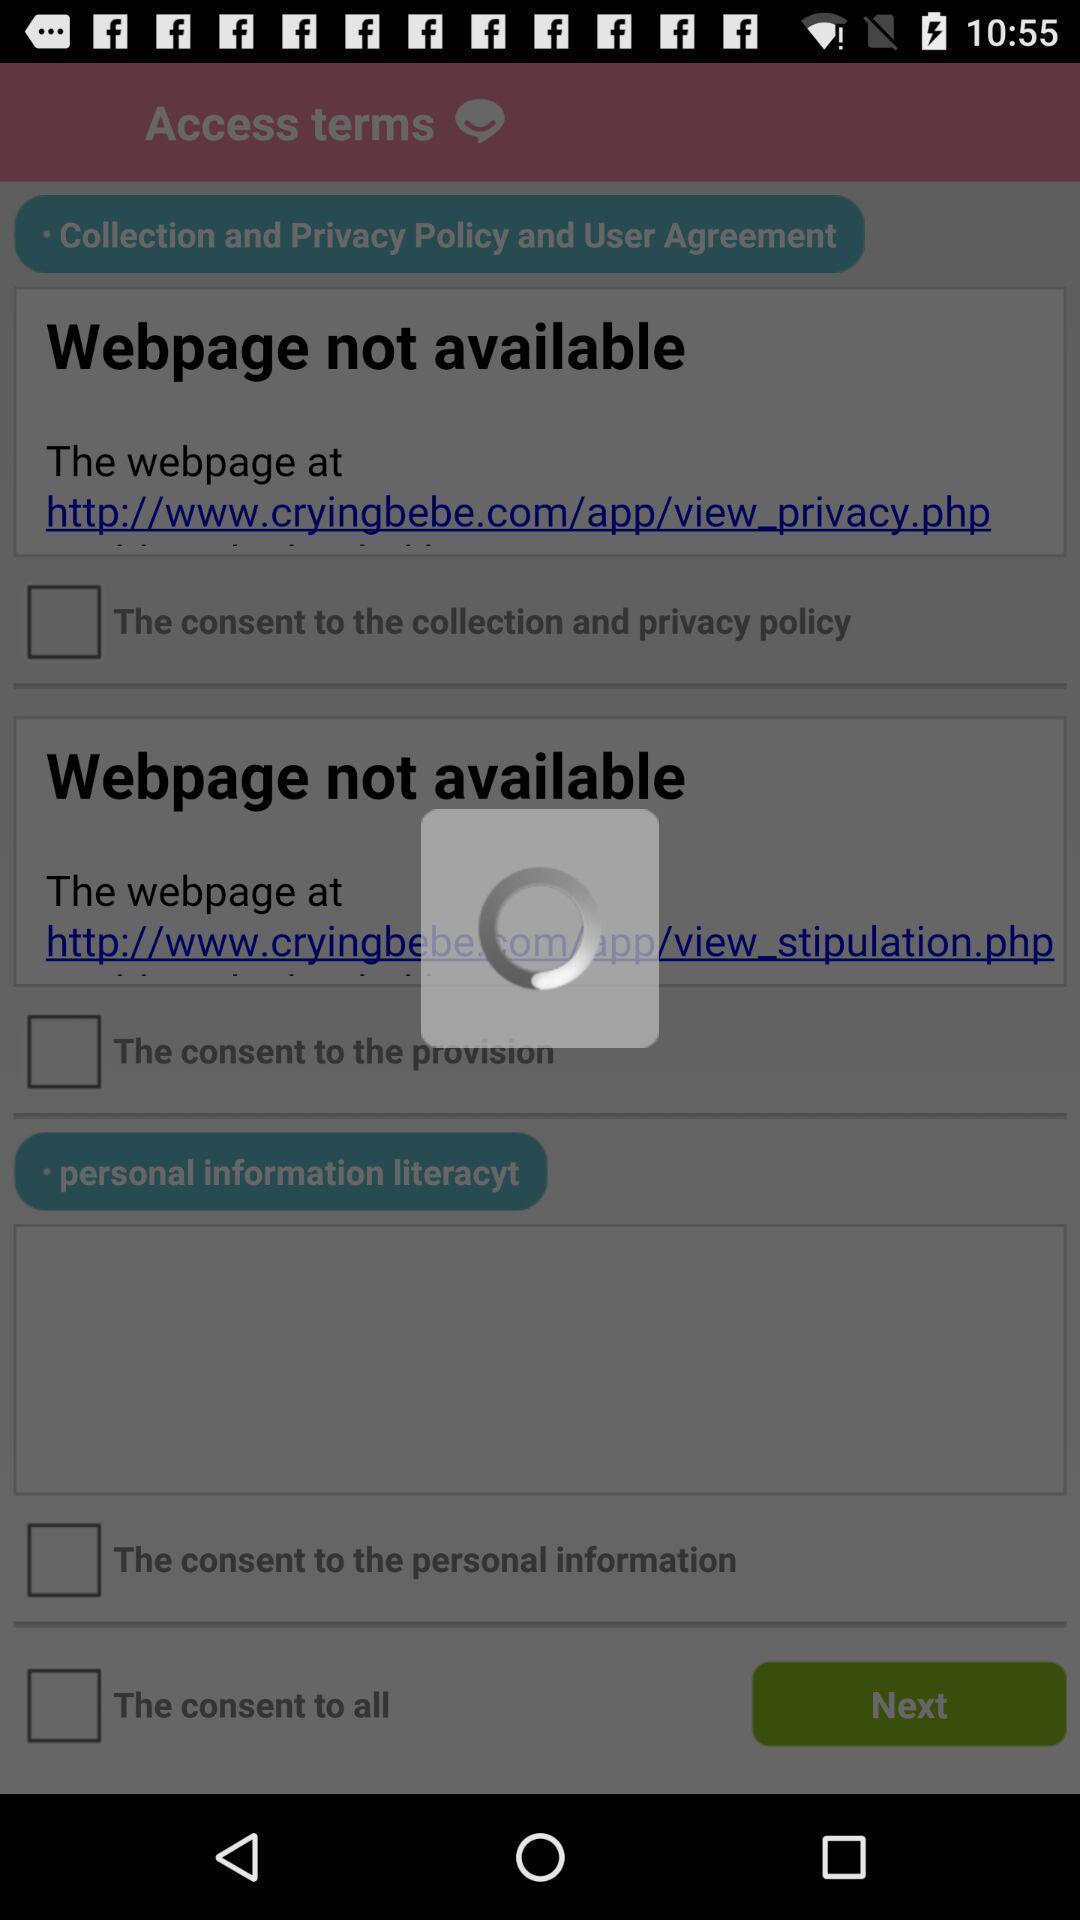Explain what's happening in this screen capture. Screen displaying the loading page with multiple options. 